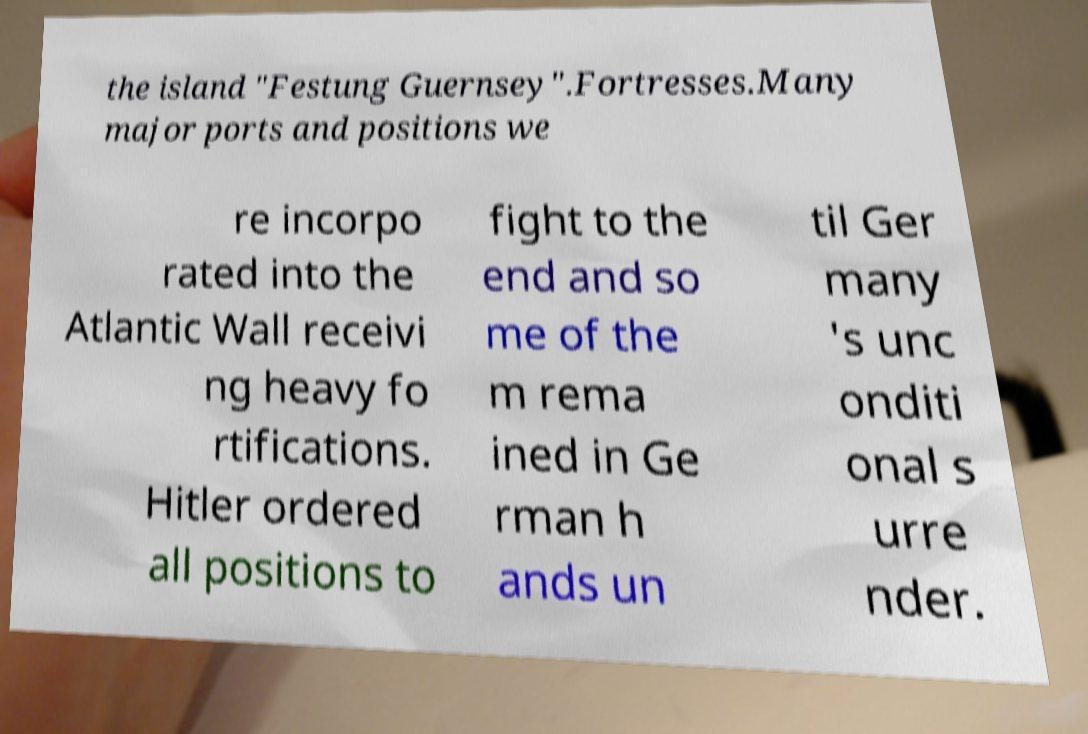For documentation purposes, I need the text within this image transcribed. Could you provide that? the island "Festung Guernsey".Fortresses.Many major ports and positions we re incorpo rated into the Atlantic Wall receivi ng heavy fo rtifications. Hitler ordered all positions to fight to the end and so me of the m rema ined in Ge rman h ands un til Ger many 's unc onditi onal s urre nder. 